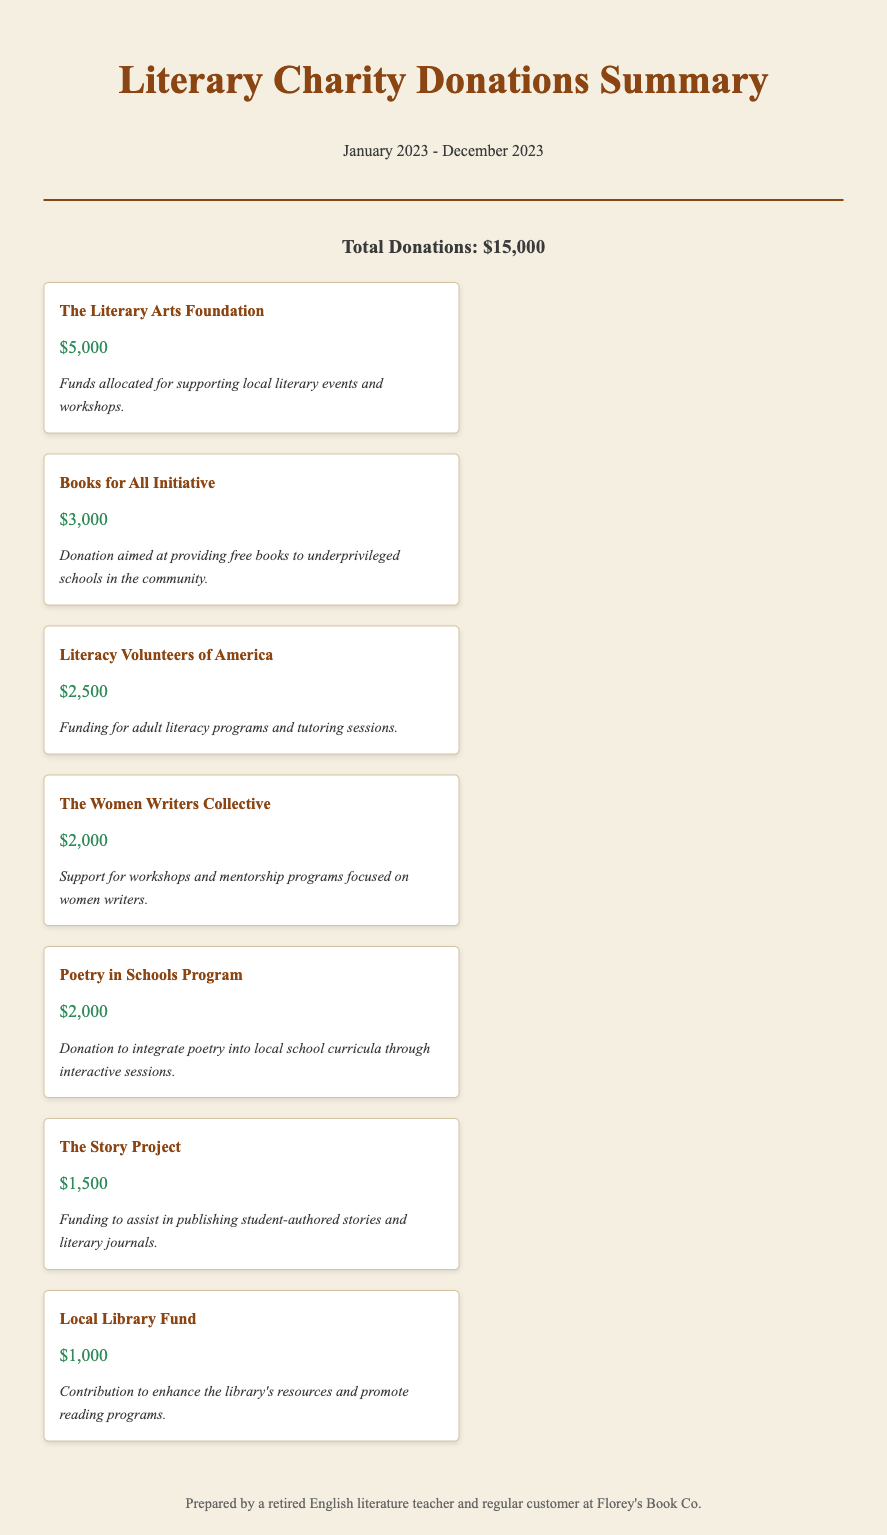What is the total amount of donations made? The total donations are listed in the summary section at the top of the document.
Answer: $15,000 Which organization received the highest donation? The organization with the highest donation amount is clearly stated in the donation list.
Answer: The Literary Arts Foundation How much was donated to the Books for All Initiative? The donation amount for each organization is provided in the respective donation item.
Answer: $3,000 What is the purpose of the donation made to Literacy Volunteers of America? Each donation item includes a description of how the funds will be used.
Answer: Funding for adult literacy programs and tutoring sessions How many organizations received donations? The total number of donation items listed in the document indicates the number of organizations.
Answer: 7 What amount was allocated to the Local Library Fund? The specific donation amount for the Local Library Fund is detailed in the donation item.
Answer: $1,000 What type of projects does The Women Writers Collective support? The description of the donation item outlines the focus of their support.
Answer: Workshops and mentorship programs focused on women writers What was the timeframe for the donations summarized in the document? The header mentions the period covered by the donations summary.
Answer: January 2023 - December 2023 What is the format of the document? The structure and content indicate it is a summary of donation transactions.
Answer: Summary of donations 